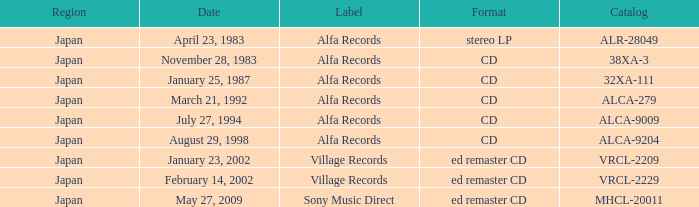Which directory is in cd format? 38XA-3, 32XA-111, ALCA-279, ALCA-9009, ALCA-9204. 